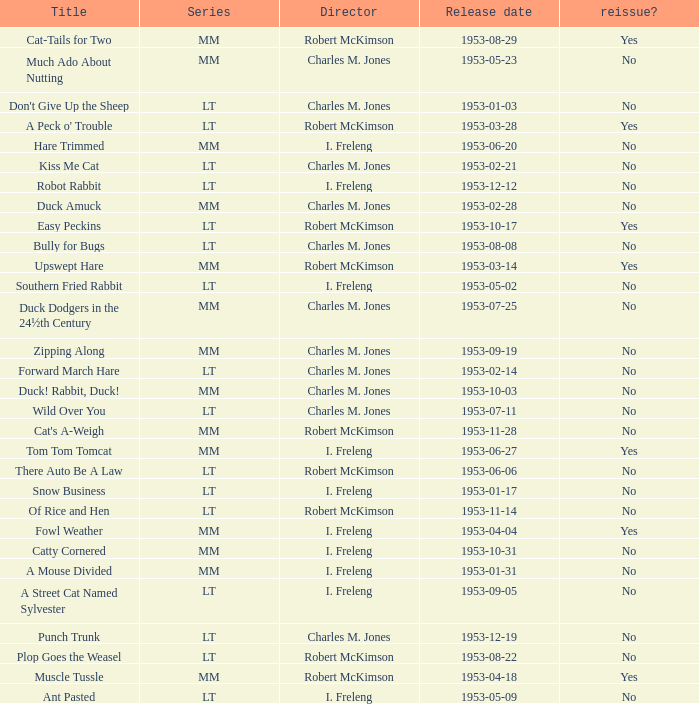What's the title for the release date of 1953-01-31 in the MM series, no reissue, and a director of I. Freleng? A Mouse Divided. 